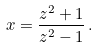Convert formula to latex. <formula><loc_0><loc_0><loc_500><loc_500>x = \frac { z ^ { 2 } + 1 } { z ^ { 2 } - 1 } \, .</formula> 